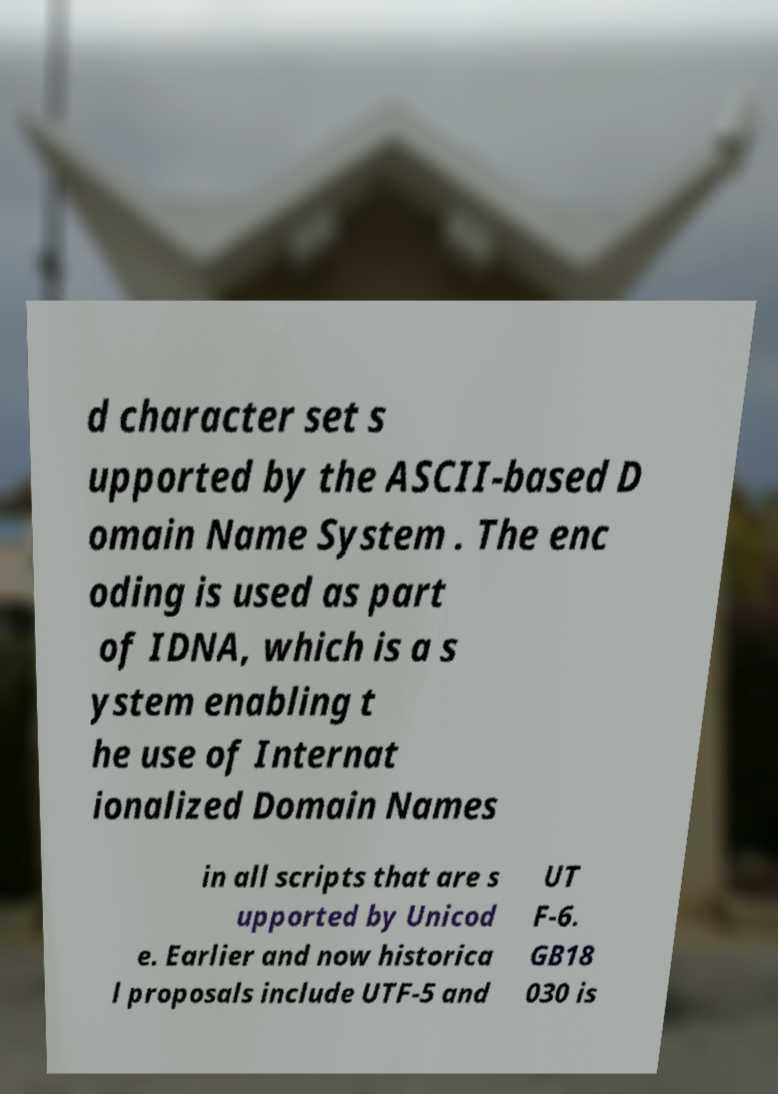I need the written content from this picture converted into text. Can you do that? d character set s upported by the ASCII-based D omain Name System . The enc oding is used as part of IDNA, which is a s ystem enabling t he use of Internat ionalized Domain Names in all scripts that are s upported by Unicod e. Earlier and now historica l proposals include UTF-5 and UT F-6. GB18 030 is 